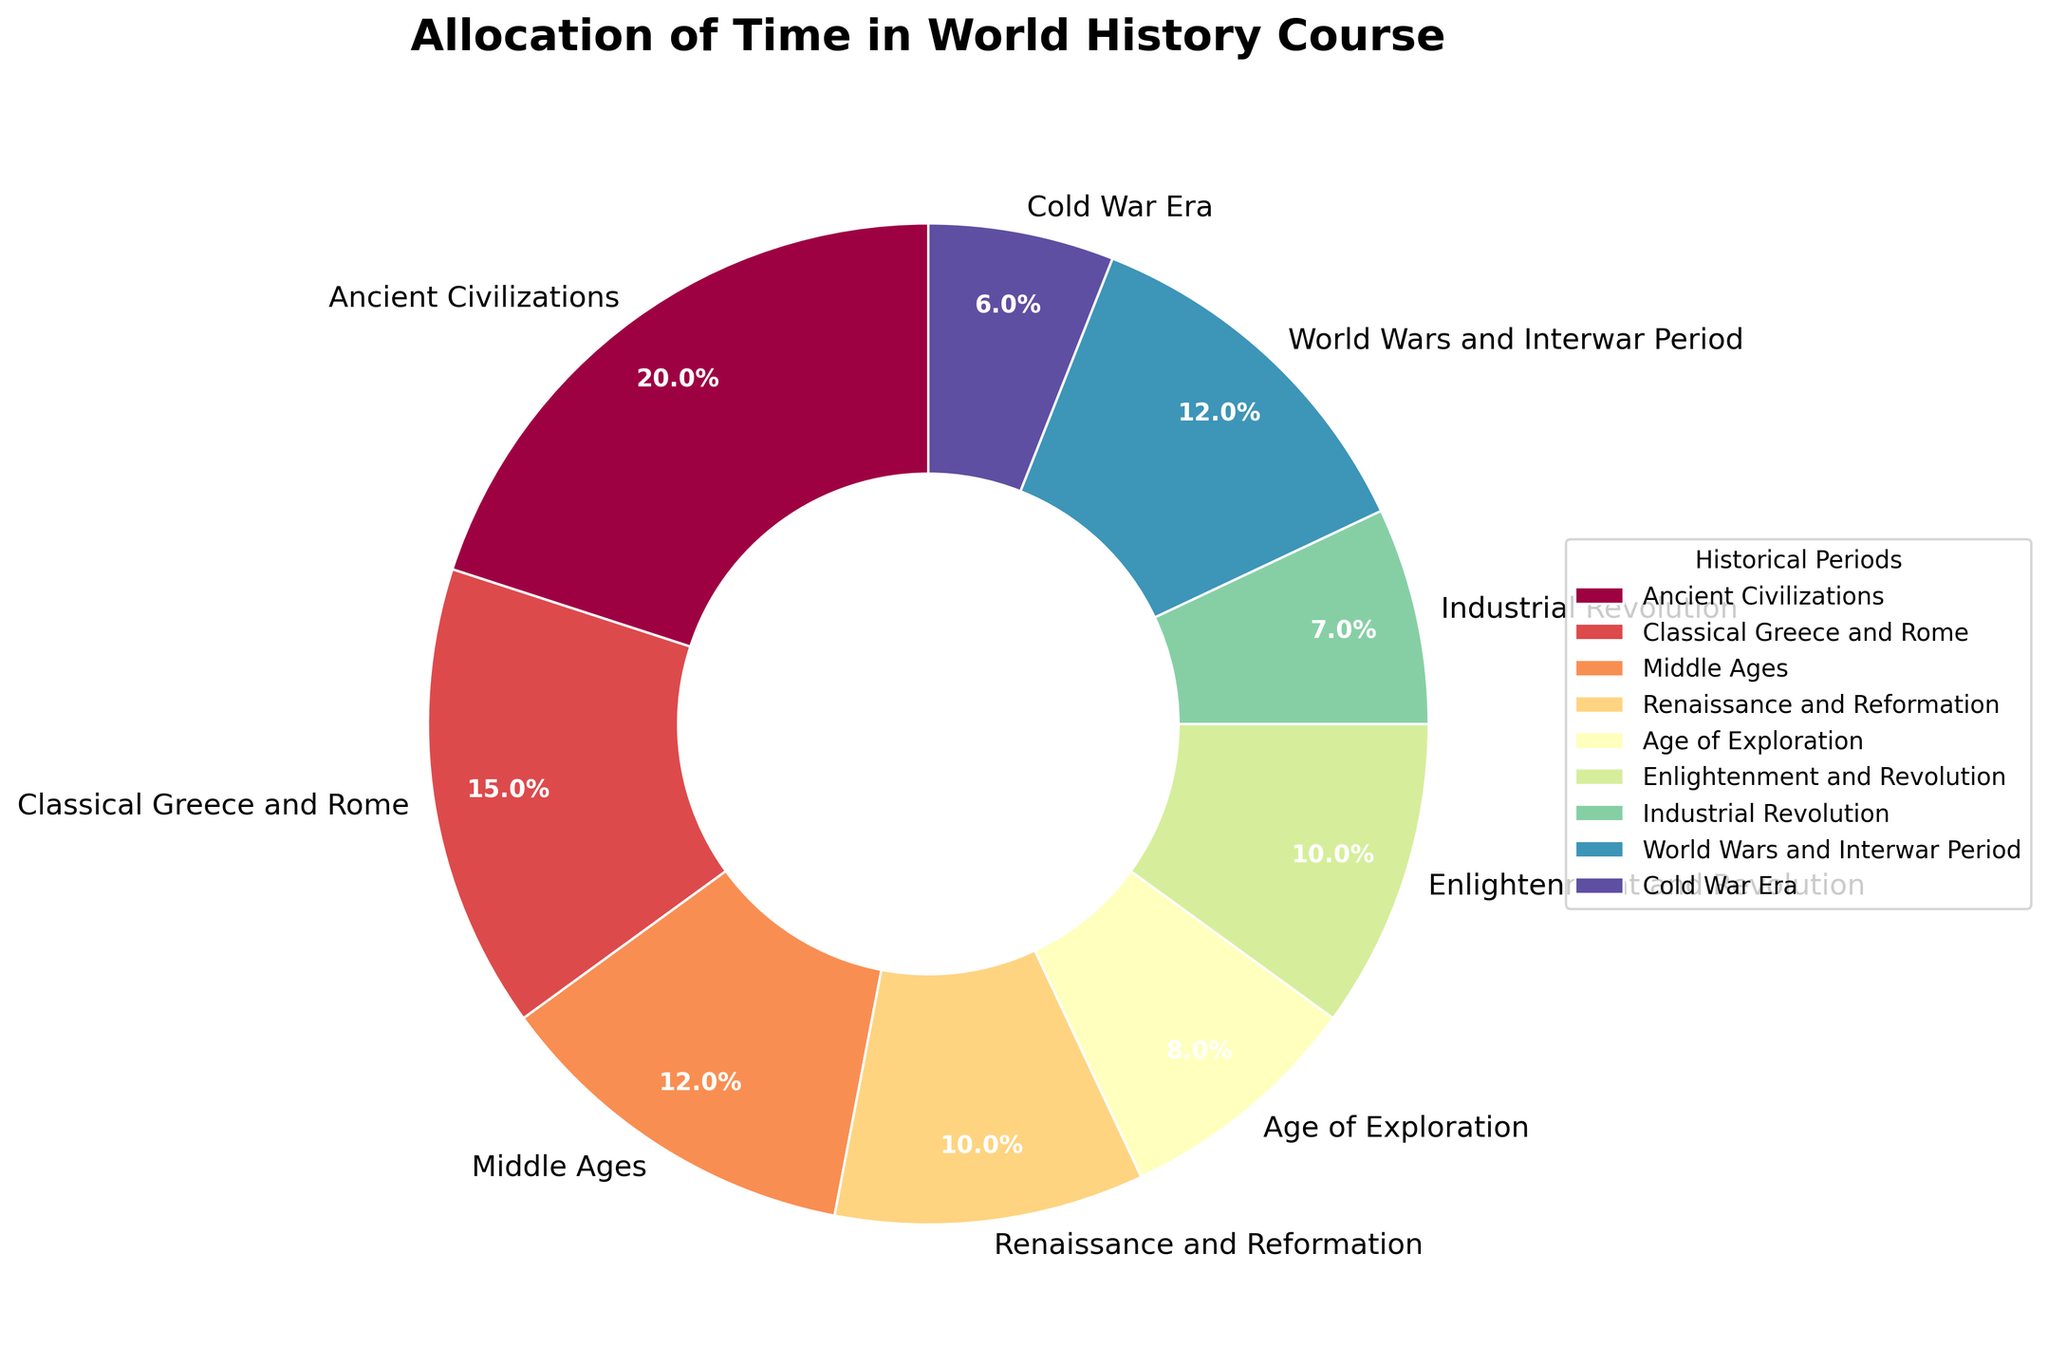What percentage of the course is dedicated to the Cold War Era? To answer this, look at the segment labeled "Cold War Era" on the pie chart, which represents 6% of the total course time.
Answer: 6% Which historical period has the highest allocation of time in the course? Identify the largest segment on the pie chart. The "Ancient Civilizations" segment appears the largest with an allocation of 20%.
Answer: Ancient Civilizations How does the time allocated to the Middle Ages compare to the Industrial Revolution? Identify the percentages for "Middle Ages" (12%) and "Industrial Revolution" (7%) on the pie chart, and compare them. The Middle Ages has a larger allocation.
Answer: Middle Ages has more time What is the combined percentage of time spent on the Renaissance and Reformation and the Enlightenment and Revolution? Look at the segments labeled "Renaissance and Reformation" (10%) and "Enlightenment and Revolution" (10%) and sum their percentages: 10% + 10% = 20%.
Answer: 20% Is more time allocated to the World Wars and Interwar Period or the Classical Greece and Rome? Check the percentages for "World Wars and Interwar Period" (12%) and "Classical Greece and Rome" (15%) and compare them.
Answer: Classical Greece and Rome Which segment comes immediately after the smallest one in the legend? Locate the smallest segment ("Cold War Era" with 6%) and see which segment follows it in the legend. The next segment is "Industrial Revolution" at 7%.
Answer: Industrial Revolution What is the total percentage of time allocated to periods before the Middle Ages (including it)? Sum the percentages for "Ancient Civilizations" (20%), "Classical Greece and Rome" (15%), and "Middle Ages" (12%): 20% + 15% + 12% = 47%.
Answer: 47% Which historical period appears in orange color on the pie chart? According to the custom color palette used in the pie chart, the "Industrial Revolution" segment is represented by the orange color.
Answer: Industrial Revolution What is the difference in time allocation between the Ancient Civilizations and the Age of Exploration? Identify the percentages for "Ancient Civilizations" (20%) and "Age of Exploration" (8%), then subtract the smaller from the larger: 20% - 8% = 12%.
Answer: 12% What is the average percentage of time allocated to the Ancient Civilizations, Classical Greece and Rome, and Renaissance and Reformation? Look at the percentages for "Ancient Civilizations" (20%), "Classical Greece and Rome" (15%), and "Renaissance and Reformation" (10%). Sum these, then divide by the number of periods: (20% + 15% + 10%) / 3 = 45% / 3 = 15%.
Answer: 15% 